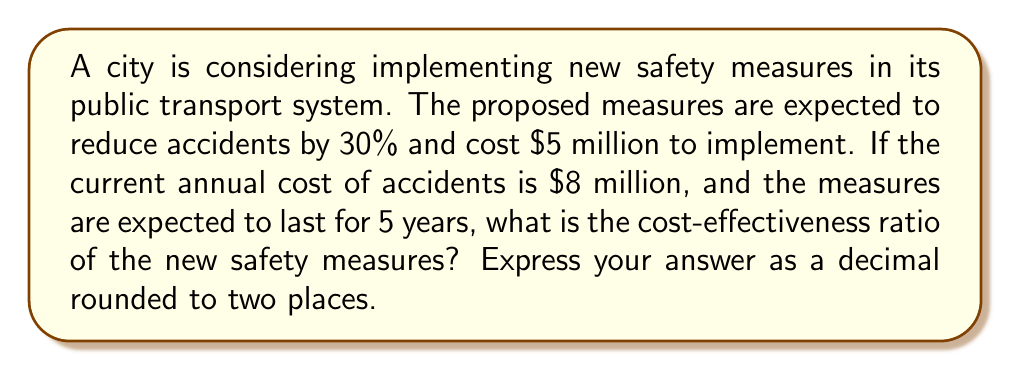What is the answer to this math problem? To calculate the cost-effectiveness ratio, we need to follow these steps:

1. Calculate the annual savings from reduced accidents:
   Current annual cost of accidents: $8 million
   Reduction in accidents: 30% = 0.30
   Annual savings = $8 million × 0.30 = $2.4 million

2. Calculate the total savings over 5 years:
   Total savings = Annual savings × 5 years
   Total savings = $2.4 million × 5 = $12 million

3. Calculate the net benefit:
   Net benefit = Total savings - Implementation cost
   Net benefit = $12 million - $5 million = $7 million

4. Calculate the cost-effectiveness ratio:
   Cost-effectiveness ratio = Net benefit / Implementation cost
   Cost-effectiveness ratio = $7 million / $5 million = 1.4

Therefore, the cost-effectiveness ratio is 1.4, which means for every dollar spent on implementation, there is a net benefit of $1.40.
Answer: 1.40 